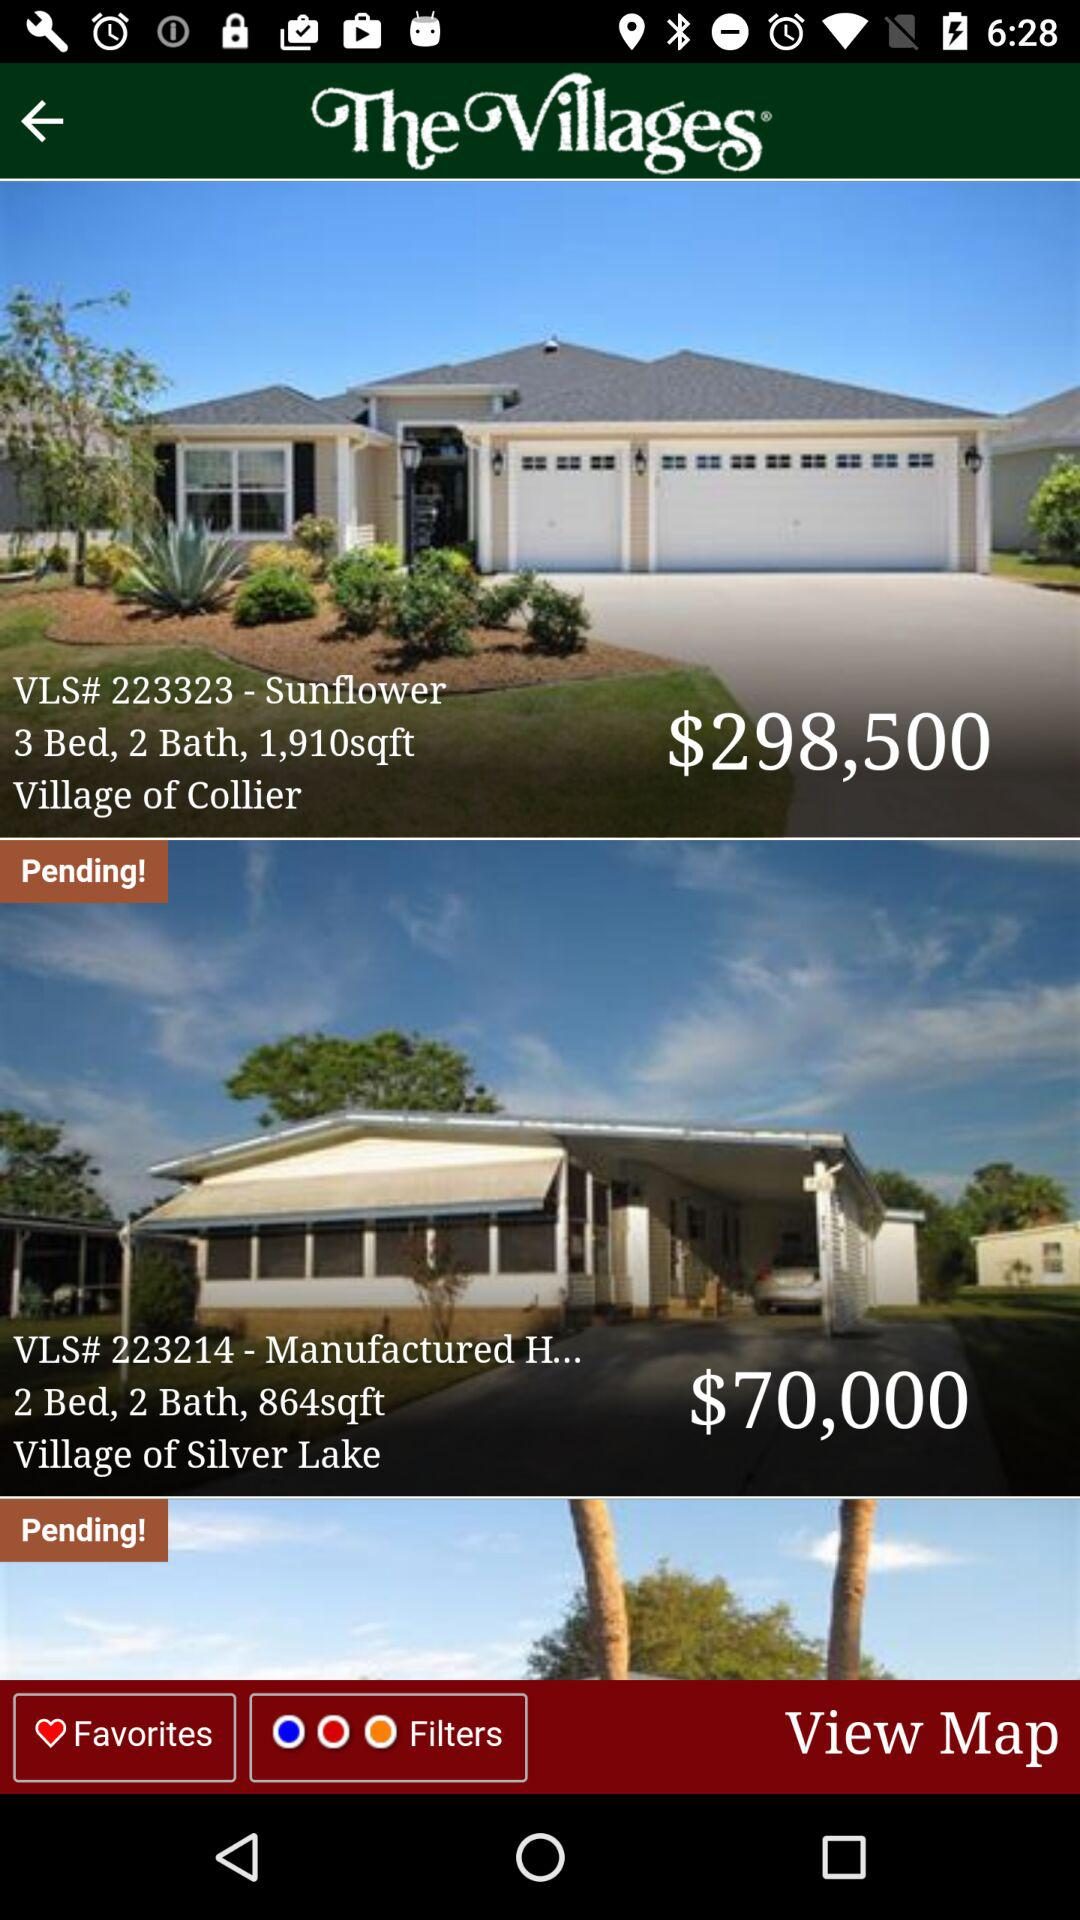What os the location of Village of silver lake?
When the provided information is insufficient, respond with <no answer>. <no answer> 